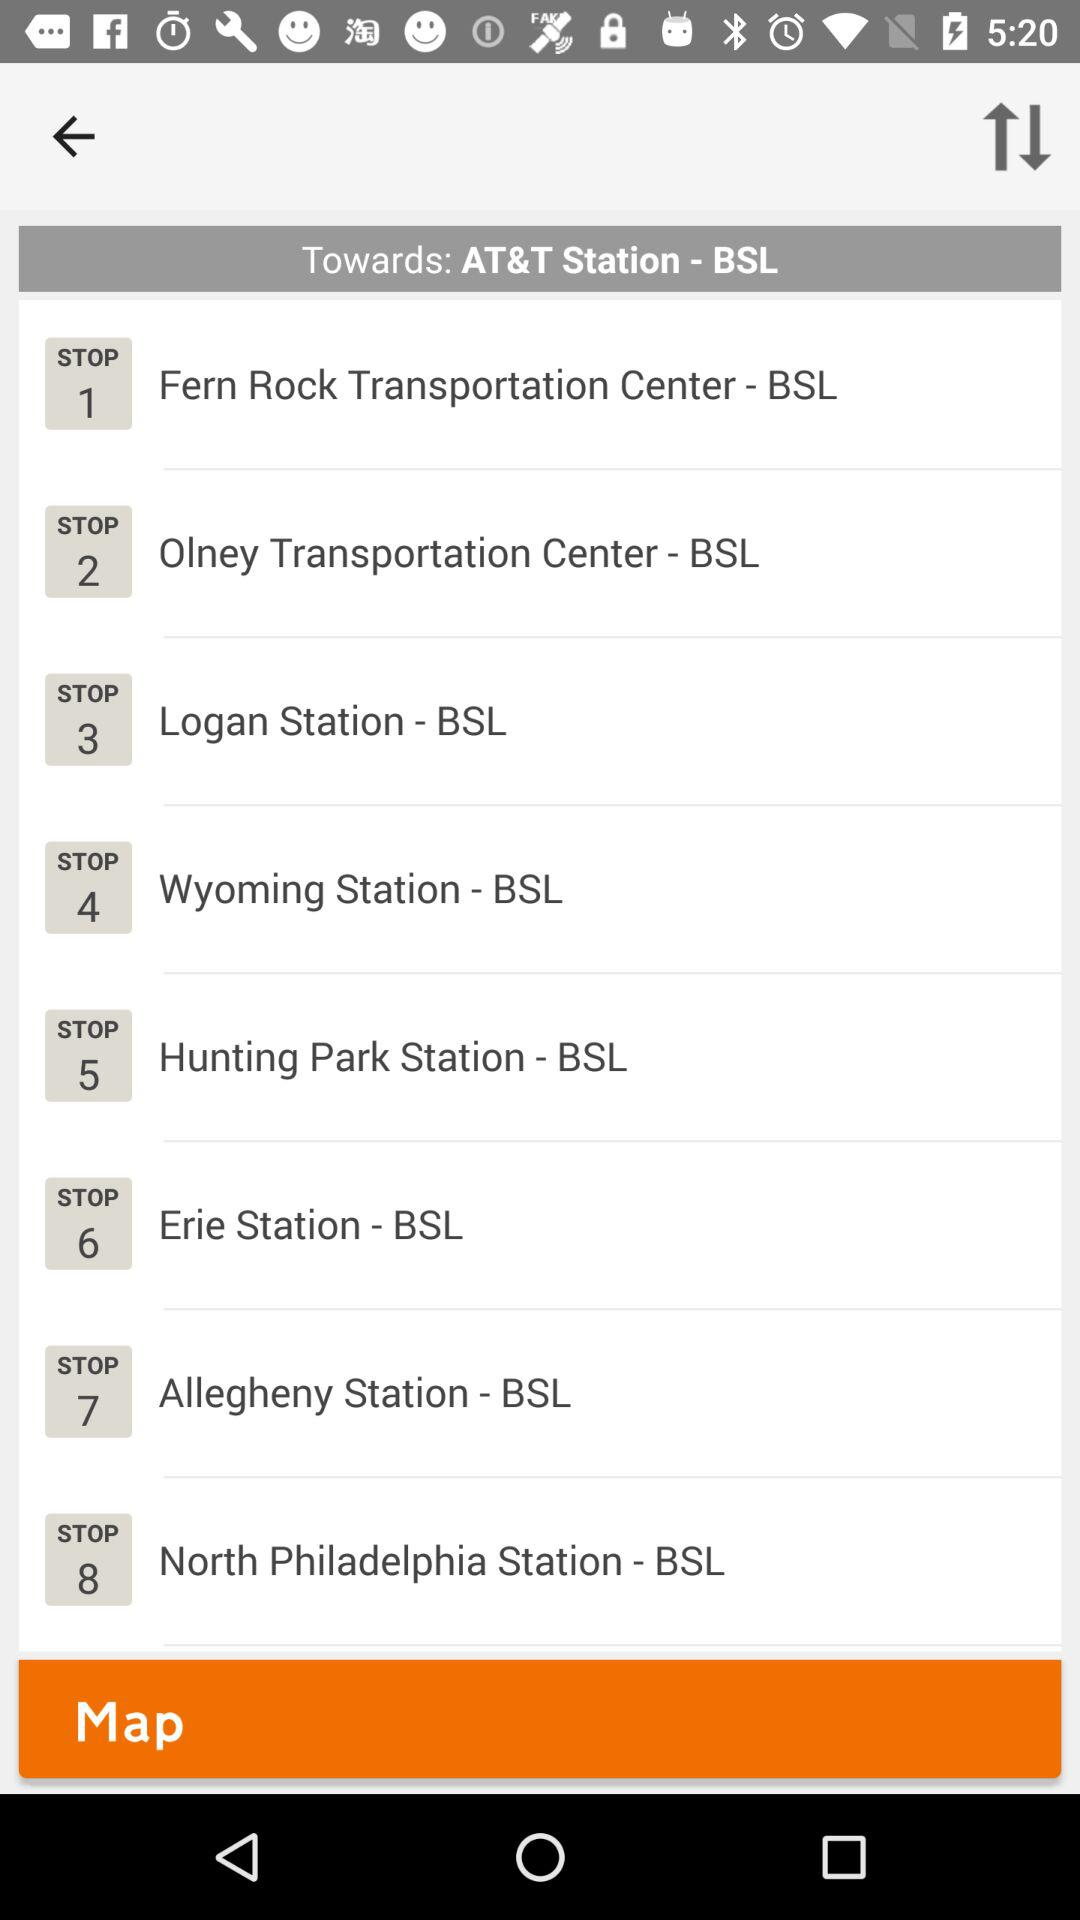What's the "Erie Station - BSL" stop number? The stop number is 6. 